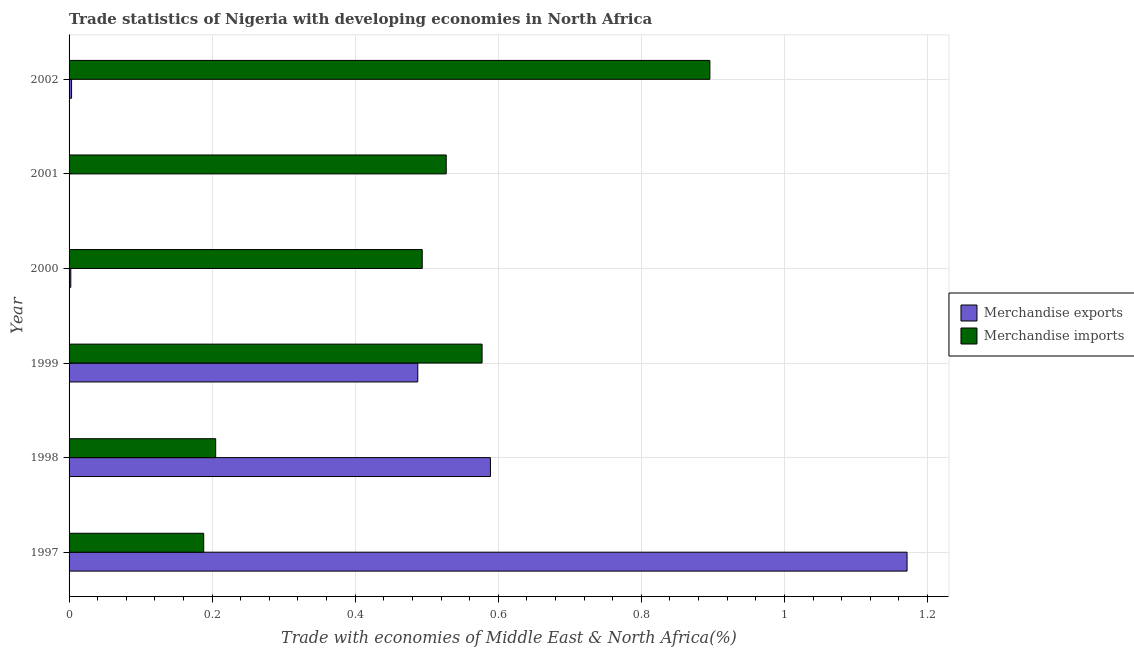How many different coloured bars are there?
Offer a terse response. 2. How many groups of bars are there?
Offer a very short reply. 6. How many bars are there on the 4th tick from the top?
Ensure brevity in your answer.  2. How many bars are there on the 2nd tick from the bottom?
Your answer should be compact. 2. In how many cases, is the number of bars for a given year not equal to the number of legend labels?
Your answer should be compact. 0. What is the merchandise imports in 2002?
Keep it short and to the point. 0.9. Across all years, what is the maximum merchandise exports?
Make the answer very short. 1.17. Across all years, what is the minimum merchandise exports?
Give a very brief answer. 9.03093325320677e-5. In which year was the merchandise exports maximum?
Give a very brief answer. 1997. What is the total merchandise imports in the graph?
Your response must be concise. 2.89. What is the difference between the merchandise exports in 2000 and that in 2002?
Ensure brevity in your answer.  -0. What is the difference between the merchandise imports in 1999 and the merchandise exports in 1998?
Provide a short and direct response. -0.01. What is the average merchandise exports per year?
Offer a terse response. 0.38. In the year 2001, what is the difference between the merchandise imports and merchandise exports?
Offer a very short reply. 0.53. In how many years, is the merchandise imports greater than 0.52 %?
Offer a very short reply. 3. What is the ratio of the merchandise exports in 1999 to that in 2002?
Make the answer very short. 139.91. Is the merchandise exports in 1997 less than that in 2000?
Make the answer very short. No. Is the difference between the merchandise imports in 1998 and 2001 greater than the difference between the merchandise exports in 1998 and 2001?
Keep it short and to the point. No. What is the difference between the highest and the second highest merchandise exports?
Give a very brief answer. 0.58. What is the difference between the highest and the lowest merchandise imports?
Provide a short and direct response. 0.71. Is the sum of the merchandise exports in 1997 and 1998 greater than the maximum merchandise imports across all years?
Provide a succinct answer. Yes. What does the 2nd bar from the bottom in 2000 represents?
Offer a terse response. Merchandise imports. How many bars are there?
Provide a short and direct response. 12. Are all the bars in the graph horizontal?
Give a very brief answer. Yes. How many years are there in the graph?
Your answer should be very brief. 6. What is the difference between two consecutive major ticks on the X-axis?
Your answer should be very brief. 0.2. Does the graph contain grids?
Your answer should be compact. Yes. Where does the legend appear in the graph?
Make the answer very short. Center right. What is the title of the graph?
Your answer should be very brief. Trade statistics of Nigeria with developing economies in North Africa. What is the label or title of the X-axis?
Ensure brevity in your answer.  Trade with economies of Middle East & North Africa(%). What is the Trade with economies of Middle East & North Africa(%) of Merchandise exports in 1997?
Offer a terse response. 1.17. What is the Trade with economies of Middle East & North Africa(%) in Merchandise imports in 1997?
Give a very brief answer. 0.19. What is the Trade with economies of Middle East & North Africa(%) in Merchandise exports in 1998?
Your answer should be very brief. 0.59. What is the Trade with economies of Middle East & North Africa(%) in Merchandise imports in 1998?
Provide a succinct answer. 0.2. What is the Trade with economies of Middle East & North Africa(%) of Merchandise exports in 1999?
Your answer should be compact. 0.49. What is the Trade with economies of Middle East & North Africa(%) in Merchandise imports in 1999?
Give a very brief answer. 0.58. What is the Trade with economies of Middle East & North Africa(%) of Merchandise exports in 2000?
Provide a short and direct response. 0. What is the Trade with economies of Middle East & North Africa(%) of Merchandise imports in 2000?
Offer a very short reply. 0.49. What is the Trade with economies of Middle East & North Africa(%) in Merchandise exports in 2001?
Offer a terse response. 9.03093325320677e-5. What is the Trade with economies of Middle East & North Africa(%) in Merchandise imports in 2001?
Offer a terse response. 0.53. What is the Trade with economies of Middle East & North Africa(%) in Merchandise exports in 2002?
Your answer should be compact. 0. What is the Trade with economies of Middle East & North Africa(%) in Merchandise imports in 2002?
Your response must be concise. 0.9. Across all years, what is the maximum Trade with economies of Middle East & North Africa(%) of Merchandise exports?
Ensure brevity in your answer.  1.17. Across all years, what is the maximum Trade with economies of Middle East & North Africa(%) of Merchandise imports?
Make the answer very short. 0.9. Across all years, what is the minimum Trade with economies of Middle East & North Africa(%) of Merchandise exports?
Your response must be concise. 9.03093325320677e-5. Across all years, what is the minimum Trade with economies of Middle East & North Africa(%) of Merchandise imports?
Give a very brief answer. 0.19. What is the total Trade with economies of Middle East & North Africa(%) of Merchandise exports in the graph?
Give a very brief answer. 2.25. What is the total Trade with economies of Middle East & North Africa(%) of Merchandise imports in the graph?
Offer a very short reply. 2.89. What is the difference between the Trade with economies of Middle East & North Africa(%) of Merchandise exports in 1997 and that in 1998?
Give a very brief answer. 0.58. What is the difference between the Trade with economies of Middle East & North Africa(%) in Merchandise imports in 1997 and that in 1998?
Your response must be concise. -0.02. What is the difference between the Trade with economies of Middle East & North Africa(%) of Merchandise exports in 1997 and that in 1999?
Offer a terse response. 0.68. What is the difference between the Trade with economies of Middle East & North Africa(%) in Merchandise imports in 1997 and that in 1999?
Give a very brief answer. -0.39. What is the difference between the Trade with economies of Middle East & North Africa(%) of Merchandise exports in 1997 and that in 2000?
Your answer should be very brief. 1.17. What is the difference between the Trade with economies of Middle East & North Africa(%) of Merchandise imports in 1997 and that in 2000?
Provide a short and direct response. -0.31. What is the difference between the Trade with economies of Middle East & North Africa(%) in Merchandise exports in 1997 and that in 2001?
Provide a short and direct response. 1.17. What is the difference between the Trade with economies of Middle East & North Africa(%) of Merchandise imports in 1997 and that in 2001?
Offer a terse response. -0.34. What is the difference between the Trade with economies of Middle East & North Africa(%) in Merchandise exports in 1997 and that in 2002?
Provide a short and direct response. 1.17. What is the difference between the Trade with economies of Middle East & North Africa(%) of Merchandise imports in 1997 and that in 2002?
Provide a succinct answer. -0.71. What is the difference between the Trade with economies of Middle East & North Africa(%) of Merchandise exports in 1998 and that in 1999?
Give a very brief answer. 0.1. What is the difference between the Trade with economies of Middle East & North Africa(%) of Merchandise imports in 1998 and that in 1999?
Make the answer very short. -0.37. What is the difference between the Trade with economies of Middle East & North Africa(%) of Merchandise exports in 1998 and that in 2000?
Your response must be concise. 0.59. What is the difference between the Trade with economies of Middle East & North Africa(%) in Merchandise imports in 1998 and that in 2000?
Your answer should be very brief. -0.29. What is the difference between the Trade with economies of Middle East & North Africa(%) of Merchandise exports in 1998 and that in 2001?
Keep it short and to the point. 0.59. What is the difference between the Trade with economies of Middle East & North Africa(%) in Merchandise imports in 1998 and that in 2001?
Offer a very short reply. -0.32. What is the difference between the Trade with economies of Middle East & North Africa(%) of Merchandise exports in 1998 and that in 2002?
Offer a very short reply. 0.59. What is the difference between the Trade with economies of Middle East & North Africa(%) of Merchandise imports in 1998 and that in 2002?
Offer a terse response. -0.69. What is the difference between the Trade with economies of Middle East & North Africa(%) in Merchandise exports in 1999 and that in 2000?
Provide a short and direct response. 0.49. What is the difference between the Trade with economies of Middle East & North Africa(%) in Merchandise imports in 1999 and that in 2000?
Provide a succinct answer. 0.08. What is the difference between the Trade with economies of Middle East & North Africa(%) of Merchandise exports in 1999 and that in 2001?
Offer a terse response. 0.49. What is the difference between the Trade with economies of Middle East & North Africa(%) in Merchandise imports in 1999 and that in 2001?
Ensure brevity in your answer.  0.05. What is the difference between the Trade with economies of Middle East & North Africa(%) of Merchandise exports in 1999 and that in 2002?
Keep it short and to the point. 0.48. What is the difference between the Trade with economies of Middle East & North Africa(%) of Merchandise imports in 1999 and that in 2002?
Your response must be concise. -0.32. What is the difference between the Trade with economies of Middle East & North Africa(%) of Merchandise exports in 2000 and that in 2001?
Your answer should be compact. 0. What is the difference between the Trade with economies of Middle East & North Africa(%) in Merchandise imports in 2000 and that in 2001?
Your answer should be very brief. -0.03. What is the difference between the Trade with economies of Middle East & North Africa(%) of Merchandise exports in 2000 and that in 2002?
Provide a short and direct response. -0. What is the difference between the Trade with economies of Middle East & North Africa(%) in Merchandise imports in 2000 and that in 2002?
Offer a very short reply. -0.4. What is the difference between the Trade with economies of Middle East & North Africa(%) of Merchandise exports in 2001 and that in 2002?
Your response must be concise. -0. What is the difference between the Trade with economies of Middle East & North Africa(%) of Merchandise imports in 2001 and that in 2002?
Offer a terse response. -0.37. What is the difference between the Trade with economies of Middle East & North Africa(%) of Merchandise exports in 1997 and the Trade with economies of Middle East & North Africa(%) of Merchandise imports in 1998?
Offer a terse response. 0.97. What is the difference between the Trade with economies of Middle East & North Africa(%) in Merchandise exports in 1997 and the Trade with economies of Middle East & North Africa(%) in Merchandise imports in 1999?
Give a very brief answer. 0.59. What is the difference between the Trade with economies of Middle East & North Africa(%) in Merchandise exports in 1997 and the Trade with economies of Middle East & North Africa(%) in Merchandise imports in 2000?
Your answer should be very brief. 0.68. What is the difference between the Trade with economies of Middle East & North Africa(%) of Merchandise exports in 1997 and the Trade with economies of Middle East & North Africa(%) of Merchandise imports in 2001?
Give a very brief answer. 0.64. What is the difference between the Trade with economies of Middle East & North Africa(%) of Merchandise exports in 1997 and the Trade with economies of Middle East & North Africa(%) of Merchandise imports in 2002?
Your answer should be compact. 0.28. What is the difference between the Trade with economies of Middle East & North Africa(%) of Merchandise exports in 1998 and the Trade with economies of Middle East & North Africa(%) of Merchandise imports in 1999?
Make the answer very short. 0.01. What is the difference between the Trade with economies of Middle East & North Africa(%) in Merchandise exports in 1998 and the Trade with economies of Middle East & North Africa(%) in Merchandise imports in 2000?
Make the answer very short. 0.1. What is the difference between the Trade with economies of Middle East & North Africa(%) of Merchandise exports in 1998 and the Trade with economies of Middle East & North Africa(%) of Merchandise imports in 2001?
Your answer should be compact. 0.06. What is the difference between the Trade with economies of Middle East & North Africa(%) of Merchandise exports in 1998 and the Trade with economies of Middle East & North Africa(%) of Merchandise imports in 2002?
Offer a terse response. -0.31. What is the difference between the Trade with economies of Middle East & North Africa(%) of Merchandise exports in 1999 and the Trade with economies of Middle East & North Africa(%) of Merchandise imports in 2000?
Ensure brevity in your answer.  -0.01. What is the difference between the Trade with economies of Middle East & North Africa(%) of Merchandise exports in 1999 and the Trade with economies of Middle East & North Africa(%) of Merchandise imports in 2001?
Your answer should be very brief. -0.04. What is the difference between the Trade with economies of Middle East & North Africa(%) of Merchandise exports in 1999 and the Trade with economies of Middle East & North Africa(%) of Merchandise imports in 2002?
Give a very brief answer. -0.41. What is the difference between the Trade with economies of Middle East & North Africa(%) of Merchandise exports in 2000 and the Trade with economies of Middle East & North Africa(%) of Merchandise imports in 2001?
Give a very brief answer. -0.52. What is the difference between the Trade with economies of Middle East & North Africa(%) in Merchandise exports in 2000 and the Trade with economies of Middle East & North Africa(%) in Merchandise imports in 2002?
Give a very brief answer. -0.89. What is the difference between the Trade with economies of Middle East & North Africa(%) of Merchandise exports in 2001 and the Trade with economies of Middle East & North Africa(%) of Merchandise imports in 2002?
Offer a terse response. -0.9. What is the average Trade with economies of Middle East & North Africa(%) in Merchandise exports per year?
Your response must be concise. 0.38. What is the average Trade with economies of Middle East & North Africa(%) of Merchandise imports per year?
Keep it short and to the point. 0.48. In the year 1997, what is the difference between the Trade with economies of Middle East & North Africa(%) in Merchandise exports and Trade with economies of Middle East & North Africa(%) in Merchandise imports?
Ensure brevity in your answer.  0.98. In the year 1998, what is the difference between the Trade with economies of Middle East & North Africa(%) in Merchandise exports and Trade with economies of Middle East & North Africa(%) in Merchandise imports?
Give a very brief answer. 0.38. In the year 1999, what is the difference between the Trade with economies of Middle East & North Africa(%) of Merchandise exports and Trade with economies of Middle East & North Africa(%) of Merchandise imports?
Your answer should be compact. -0.09. In the year 2000, what is the difference between the Trade with economies of Middle East & North Africa(%) in Merchandise exports and Trade with economies of Middle East & North Africa(%) in Merchandise imports?
Ensure brevity in your answer.  -0.49. In the year 2001, what is the difference between the Trade with economies of Middle East & North Africa(%) of Merchandise exports and Trade with economies of Middle East & North Africa(%) of Merchandise imports?
Your answer should be very brief. -0.53. In the year 2002, what is the difference between the Trade with economies of Middle East & North Africa(%) in Merchandise exports and Trade with economies of Middle East & North Africa(%) in Merchandise imports?
Make the answer very short. -0.89. What is the ratio of the Trade with economies of Middle East & North Africa(%) of Merchandise exports in 1997 to that in 1998?
Provide a short and direct response. 1.99. What is the ratio of the Trade with economies of Middle East & North Africa(%) of Merchandise imports in 1997 to that in 1998?
Your answer should be very brief. 0.92. What is the ratio of the Trade with economies of Middle East & North Africa(%) of Merchandise exports in 1997 to that in 1999?
Ensure brevity in your answer.  2.4. What is the ratio of the Trade with economies of Middle East & North Africa(%) in Merchandise imports in 1997 to that in 1999?
Keep it short and to the point. 0.33. What is the ratio of the Trade with economies of Middle East & North Africa(%) in Merchandise exports in 1997 to that in 2000?
Ensure brevity in your answer.  484.59. What is the ratio of the Trade with economies of Middle East & North Africa(%) of Merchandise imports in 1997 to that in 2000?
Make the answer very short. 0.38. What is the ratio of the Trade with economies of Middle East & North Africa(%) in Merchandise exports in 1997 to that in 2001?
Provide a short and direct response. 1.30e+04. What is the ratio of the Trade with economies of Middle East & North Africa(%) of Merchandise imports in 1997 to that in 2001?
Your answer should be very brief. 0.36. What is the ratio of the Trade with economies of Middle East & North Africa(%) of Merchandise exports in 1997 to that in 2002?
Ensure brevity in your answer.  336.23. What is the ratio of the Trade with economies of Middle East & North Africa(%) in Merchandise imports in 1997 to that in 2002?
Give a very brief answer. 0.21. What is the ratio of the Trade with economies of Middle East & North Africa(%) of Merchandise exports in 1998 to that in 1999?
Your answer should be compact. 1.21. What is the ratio of the Trade with economies of Middle East & North Africa(%) in Merchandise imports in 1998 to that in 1999?
Offer a very short reply. 0.35. What is the ratio of the Trade with economies of Middle East & North Africa(%) in Merchandise exports in 1998 to that in 2000?
Offer a very short reply. 243.67. What is the ratio of the Trade with economies of Middle East & North Africa(%) of Merchandise imports in 1998 to that in 2000?
Keep it short and to the point. 0.42. What is the ratio of the Trade with economies of Middle East & North Africa(%) in Merchandise exports in 1998 to that in 2001?
Your answer should be very brief. 6522.78. What is the ratio of the Trade with economies of Middle East & North Africa(%) in Merchandise imports in 1998 to that in 2001?
Offer a terse response. 0.39. What is the ratio of the Trade with economies of Middle East & North Africa(%) of Merchandise exports in 1998 to that in 2002?
Offer a very short reply. 169.07. What is the ratio of the Trade with economies of Middle East & North Africa(%) in Merchandise imports in 1998 to that in 2002?
Your answer should be very brief. 0.23. What is the ratio of the Trade with economies of Middle East & North Africa(%) in Merchandise exports in 1999 to that in 2000?
Your response must be concise. 201.65. What is the ratio of the Trade with economies of Middle East & North Africa(%) of Merchandise imports in 1999 to that in 2000?
Keep it short and to the point. 1.17. What is the ratio of the Trade with economies of Middle East & North Africa(%) of Merchandise exports in 1999 to that in 2001?
Give a very brief answer. 5397.85. What is the ratio of the Trade with economies of Middle East & North Africa(%) in Merchandise imports in 1999 to that in 2001?
Make the answer very short. 1.1. What is the ratio of the Trade with economies of Middle East & North Africa(%) in Merchandise exports in 1999 to that in 2002?
Provide a short and direct response. 139.91. What is the ratio of the Trade with economies of Middle East & North Africa(%) of Merchandise imports in 1999 to that in 2002?
Keep it short and to the point. 0.64. What is the ratio of the Trade with economies of Middle East & North Africa(%) of Merchandise exports in 2000 to that in 2001?
Make the answer very short. 26.77. What is the ratio of the Trade with economies of Middle East & North Africa(%) in Merchandise imports in 2000 to that in 2001?
Your answer should be very brief. 0.94. What is the ratio of the Trade with economies of Middle East & North Africa(%) in Merchandise exports in 2000 to that in 2002?
Ensure brevity in your answer.  0.69. What is the ratio of the Trade with economies of Middle East & North Africa(%) of Merchandise imports in 2000 to that in 2002?
Give a very brief answer. 0.55. What is the ratio of the Trade with economies of Middle East & North Africa(%) of Merchandise exports in 2001 to that in 2002?
Give a very brief answer. 0.03. What is the ratio of the Trade with economies of Middle East & North Africa(%) of Merchandise imports in 2001 to that in 2002?
Your answer should be compact. 0.59. What is the difference between the highest and the second highest Trade with economies of Middle East & North Africa(%) of Merchandise exports?
Your answer should be compact. 0.58. What is the difference between the highest and the second highest Trade with economies of Middle East & North Africa(%) of Merchandise imports?
Keep it short and to the point. 0.32. What is the difference between the highest and the lowest Trade with economies of Middle East & North Africa(%) of Merchandise exports?
Ensure brevity in your answer.  1.17. What is the difference between the highest and the lowest Trade with economies of Middle East & North Africa(%) in Merchandise imports?
Your response must be concise. 0.71. 